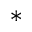Convert formula to latex. <formula><loc_0><loc_0><loc_500><loc_500>^ { * }</formula> 